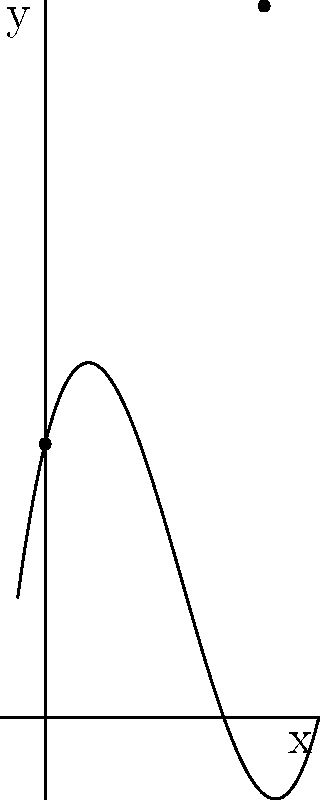During a match at Vulcan Newton F.C.'s home ground, you ran a peculiar path that can be represented by the polynomial function $f(x) = 0.1x^3 - 1.5x^2 + 4x + 10$, where $x$ represents the distance along the sideline in meters and $f(x)$ represents your distance from the sideline in meters. If you started at the corner flag $(0,10)$ and ended at a point $(8,26)$, what was the total distance you ran along this path? To find the total distance run along the path, we need to calculate the arc length of the curve between $x=0$ and $x=8$. The formula for arc length is:

$$L = \int_a^b \sqrt{1 + [f'(x)]^2} dx$$

Steps:
1) First, find $f'(x)$:
   $f'(x) = 0.3x^2 - 3x + 4$

2) Substitute into the arc length formula:
   $$L = \int_0^8 \sqrt{1 + (0.3x^2 - 3x + 4)^2} dx$$

3) This integral is complex and cannot be solved easily by hand. We need to use numerical integration methods or a computer algebra system.

4) Using a numerical integration method, we get:
   $$L \approx 20.76$$

Therefore, the total distance run along this path is approximately 20.76 meters.
Answer: 20.76 meters 